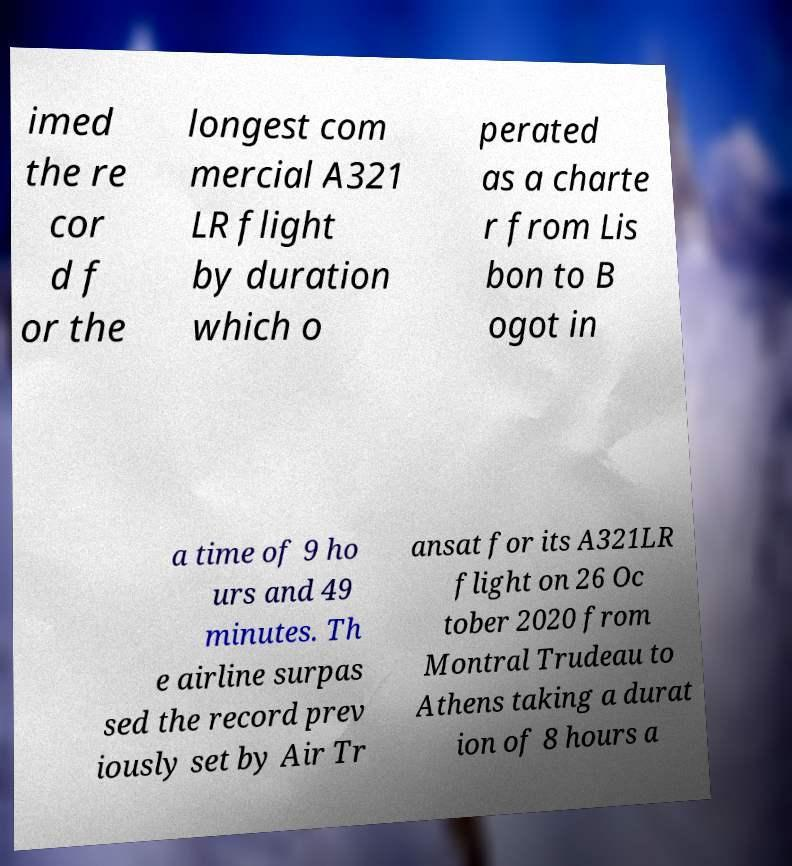Can you read and provide the text displayed in the image?This photo seems to have some interesting text. Can you extract and type it out for me? imed the re cor d f or the longest com mercial A321 LR flight by duration which o perated as a charte r from Lis bon to B ogot in a time of 9 ho urs and 49 minutes. Th e airline surpas sed the record prev iously set by Air Tr ansat for its A321LR flight on 26 Oc tober 2020 from Montral Trudeau to Athens taking a durat ion of 8 hours a 